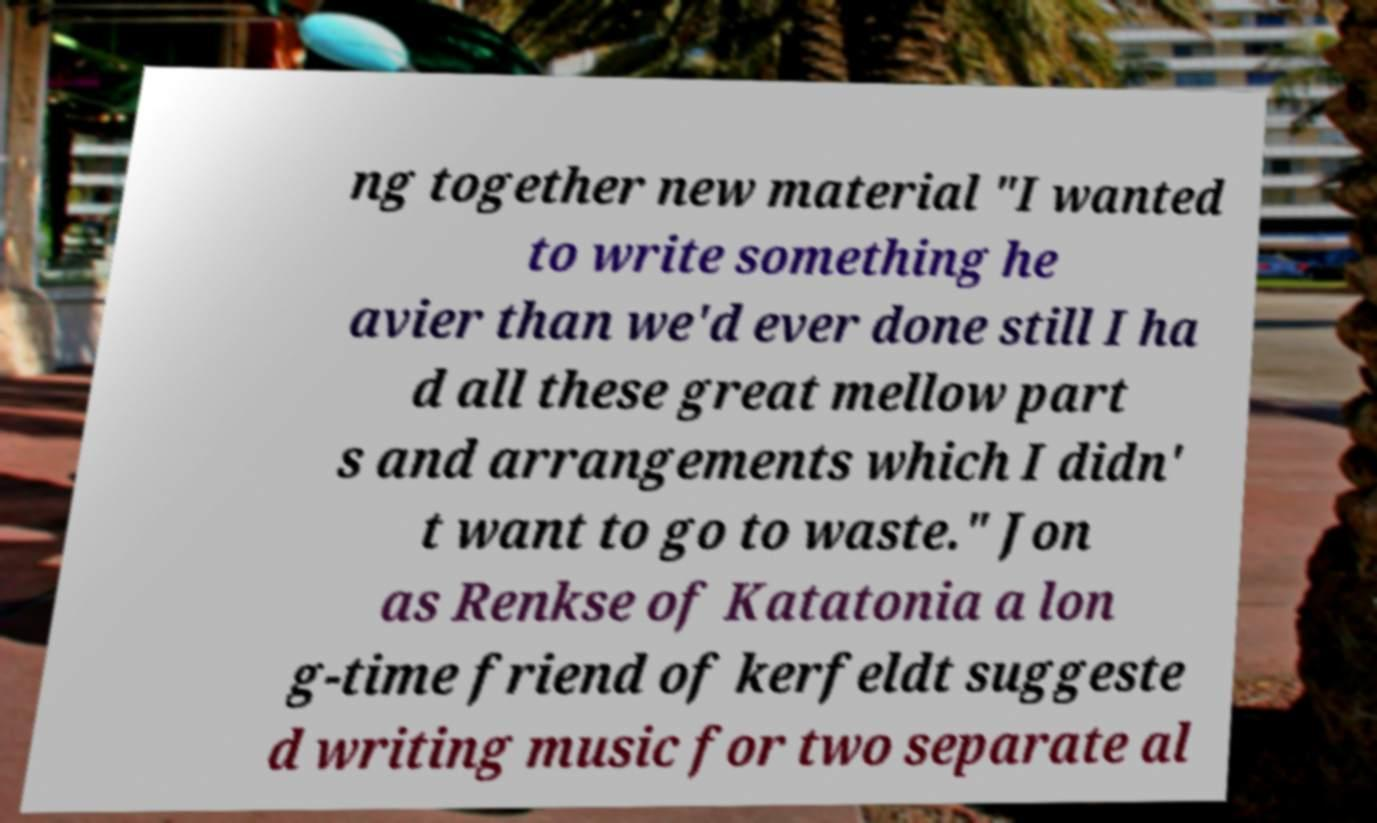There's text embedded in this image that I need extracted. Can you transcribe it verbatim? ng together new material "I wanted to write something he avier than we'd ever done still I ha d all these great mellow part s and arrangements which I didn' t want to go to waste." Jon as Renkse of Katatonia a lon g-time friend of kerfeldt suggeste d writing music for two separate al 